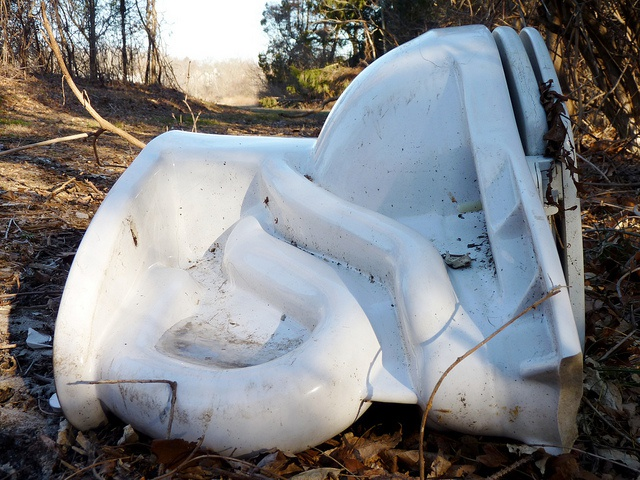Describe the objects in this image and their specific colors. I can see a toilet in maroon, lightgray, darkgray, and gray tones in this image. 